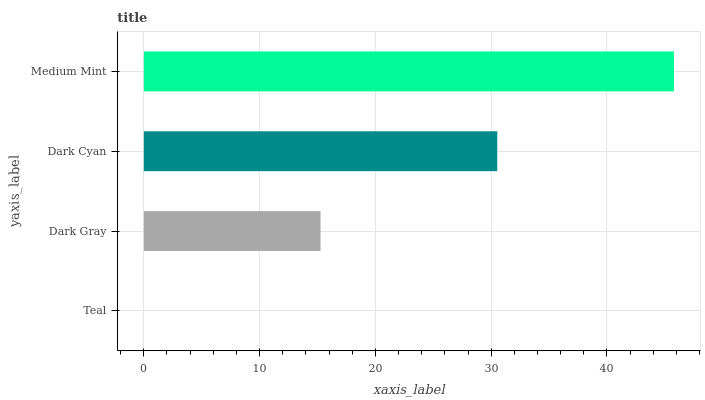Is Teal the minimum?
Answer yes or no. Yes. Is Medium Mint the maximum?
Answer yes or no. Yes. Is Dark Gray the minimum?
Answer yes or no. No. Is Dark Gray the maximum?
Answer yes or no. No. Is Dark Gray greater than Teal?
Answer yes or no. Yes. Is Teal less than Dark Gray?
Answer yes or no. Yes. Is Teal greater than Dark Gray?
Answer yes or no. No. Is Dark Gray less than Teal?
Answer yes or no. No. Is Dark Cyan the high median?
Answer yes or no. Yes. Is Dark Gray the low median?
Answer yes or no. Yes. Is Teal the high median?
Answer yes or no. No. Is Dark Cyan the low median?
Answer yes or no. No. 